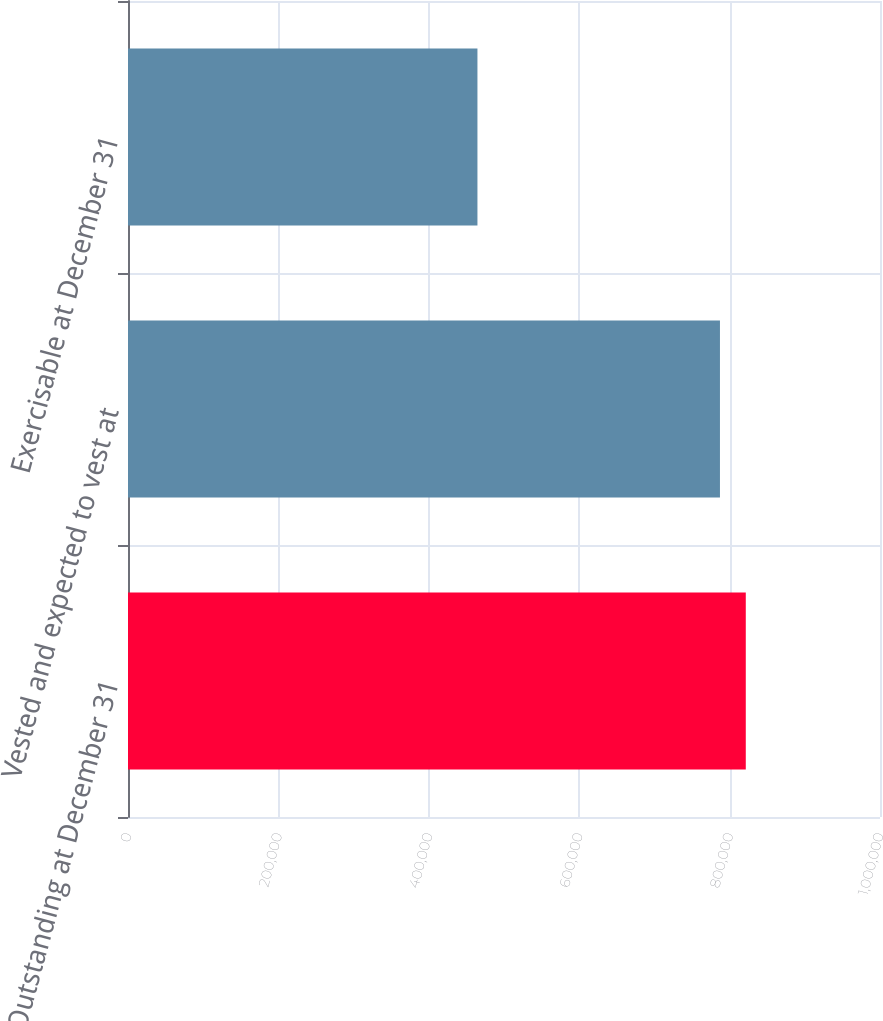<chart> <loc_0><loc_0><loc_500><loc_500><bar_chart><fcel>Outstanding at December 31<fcel>Vested and expected to vest at<fcel>Exercisable at December 31<nl><fcel>821518<fcel>787182<fcel>464685<nl></chart> 